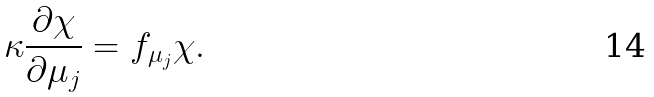Convert formula to latex. <formula><loc_0><loc_0><loc_500><loc_500>\kappa \frac { \partial \chi } { \partial \mu _ { j } } = f _ { \mu _ { j } } \chi .</formula> 